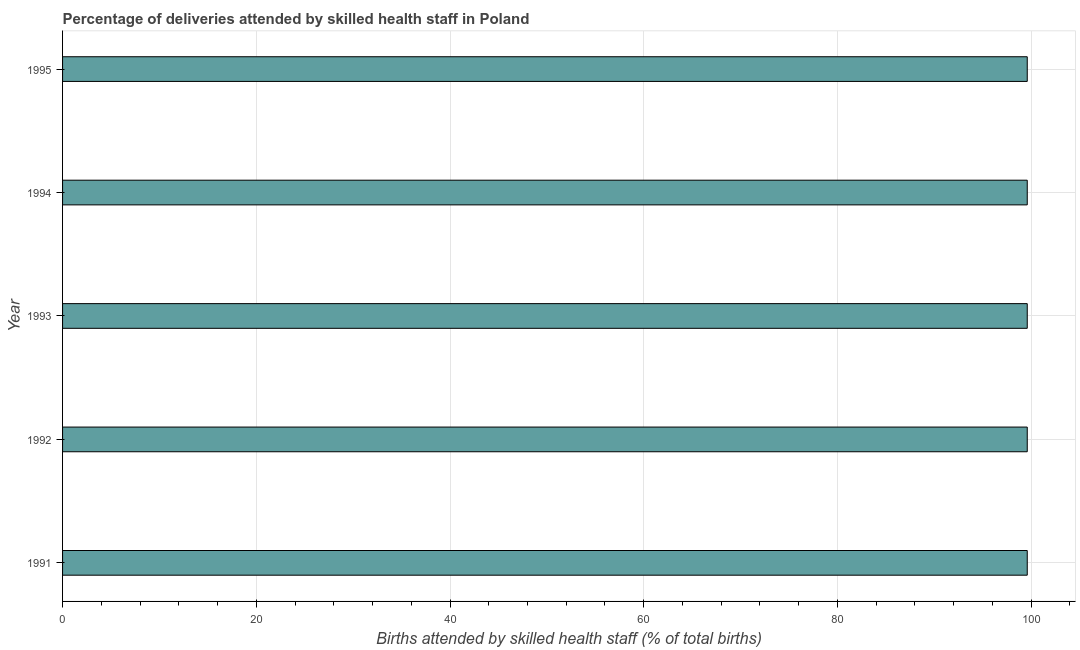Does the graph contain any zero values?
Your answer should be very brief. No. What is the title of the graph?
Offer a terse response. Percentage of deliveries attended by skilled health staff in Poland. What is the label or title of the X-axis?
Your answer should be very brief. Births attended by skilled health staff (% of total births). What is the number of births attended by skilled health staff in 1995?
Your response must be concise. 99.6. Across all years, what is the maximum number of births attended by skilled health staff?
Give a very brief answer. 99.6. Across all years, what is the minimum number of births attended by skilled health staff?
Give a very brief answer. 99.6. In which year was the number of births attended by skilled health staff maximum?
Give a very brief answer. 1991. In which year was the number of births attended by skilled health staff minimum?
Your answer should be compact. 1991. What is the sum of the number of births attended by skilled health staff?
Keep it short and to the point. 498. What is the difference between the number of births attended by skilled health staff in 1992 and 1993?
Provide a short and direct response. 0. What is the average number of births attended by skilled health staff per year?
Your answer should be very brief. 99.6. What is the median number of births attended by skilled health staff?
Keep it short and to the point. 99.6. In how many years, is the number of births attended by skilled health staff greater than 32 %?
Offer a terse response. 5. Do a majority of the years between 1993 and 1995 (inclusive) have number of births attended by skilled health staff greater than 92 %?
Provide a short and direct response. Yes. Is the number of births attended by skilled health staff in 1992 less than that in 1994?
Your response must be concise. No. What is the difference between the highest and the second highest number of births attended by skilled health staff?
Ensure brevity in your answer.  0. What is the difference between the highest and the lowest number of births attended by skilled health staff?
Provide a succinct answer. 0. In how many years, is the number of births attended by skilled health staff greater than the average number of births attended by skilled health staff taken over all years?
Provide a short and direct response. 0. Are all the bars in the graph horizontal?
Your answer should be compact. Yes. How many years are there in the graph?
Offer a very short reply. 5. What is the difference between two consecutive major ticks on the X-axis?
Provide a succinct answer. 20. What is the Births attended by skilled health staff (% of total births) in 1991?
Provide a succinct answer. 99.6. What is the Births attended by skilled health staff (% of total births) in 1992?
Your answer should be compact. 99.6. What is the Births attended by skilled health staff (% of total births) of 1993?
Offer a very short reply. 99.6. What is the Births attended by skilled health staff (% of total births) of 1994?
Offer a terse response. 99.6. What is the Births attended by skilled health staff (% of total births) in 1995?
Offer a terse response. 99.6. What is the difference between the Births attended by skilled health staff (% of total births) in 1991 and 1993?
Your response must be concise. 0. What is the difference between the Births attended by skilled health staff (% of total births) in 1991 and 1995?
Your answer should be compact. 0. What is the difference between the Births attended by skilled health staff (% of total births) in 1992 and 1994?
Your response must be concise. 0. What is the ratio of the Births attended by skilled health staff (% of total births) in 1991 to that in 1992?
Offer a terse response. 1. What is the ratio of the Births attended by skilled health staff (% of total births) in 1991 to that in 1993?
Give a very brief answer. 1. What is the ratio of the Births attended by skilled health staff (% of total births) in 1992 to that in 1993?
Make the answer very short. 1. What is the ratio of the Births attended by skilled health staff (% of total births) in 1992 to that in 1994?
Offer a very short reply. 1. What is the ratio of the Births attended by skilled health staff (% of total births) in 1992 to that in 1995?
Your answer should be very brief. 1. What is the ratio of the Births attended by skilled health staff (% of total births) in 1993 to that in 1994?
Give a very brief answer. 1. What is the ratio of the Births attended by skilled health staff (% of total births) in 1993 to that in 1995?
Offer a very short reply. 1. What is the ratio of the Births attended by skilled health staff (% of total births) in 1994 to that in 1995?
Make the answer very short. 1. 